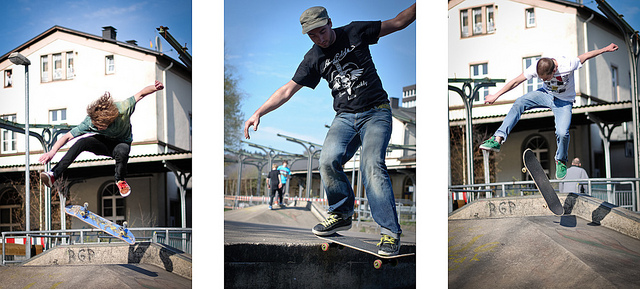Identify and read out the text in this image. RGP RGP 